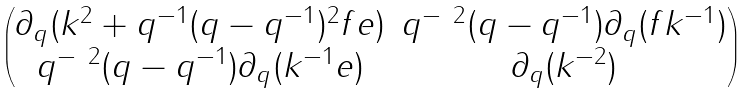Convert formula to latex. <formula><loc_0><loc_0><loc_500><loc_500>\begin{pmatrix} \partial _ { q } ( k ^ { 2 } + q ^ { - 1 } ( q - q ^ { - 1 } ) ^ { 2 } f e ) & q ^ { - \ 2 } ( q - q ^ { - 1 } ) \partial _ { q } ( f k ^ { - 1 } ) \\ q ^ { - \ 2 } ( q - q ^ { - 1 } ) \partial _ { q } ( k ^ { - 1 } e ) & \partial _ { q } ( k ^ { - 2 } ) \end{pmatrix}</formula> 